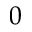Convert formula to latex. <formula><loc_0><loc_0><loc_500><loc_500>0</formula> 